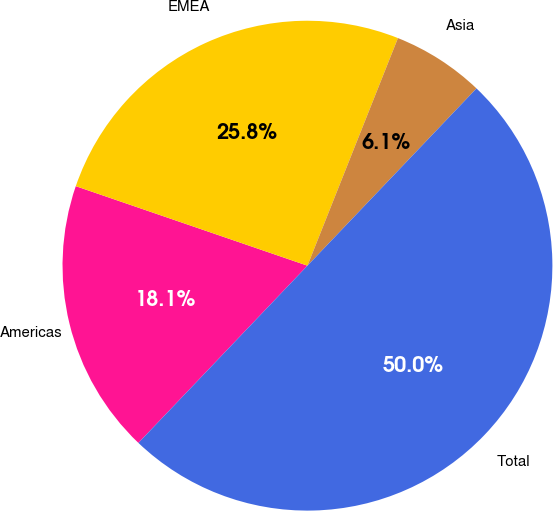Convert chart. <chart><loc_0><loc_0><loc_500><loc_500><pie_chart><fcel>Americas<fcel>EMEA<fcel>Asia<fcel>Total<nl><fcel>18.14%<fcel>25.76%<fcel>6.1%<fcel>50.0%<nl></chart> 